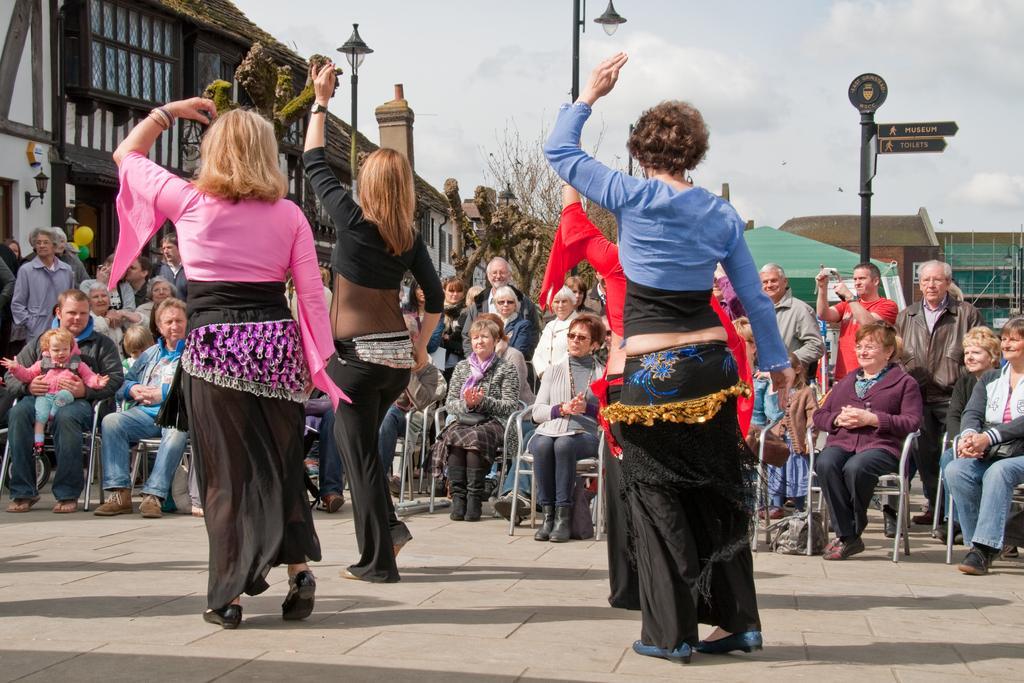Please provide a concise description of this image. This image is clicked on the road. In the foreground there are four people dancing on the road. In front of them there are people sitting on the chairs. There are a few people standing behind them. In the background there are buildings, street lights poles, sign board poles and trees. At the top there is the sky. 